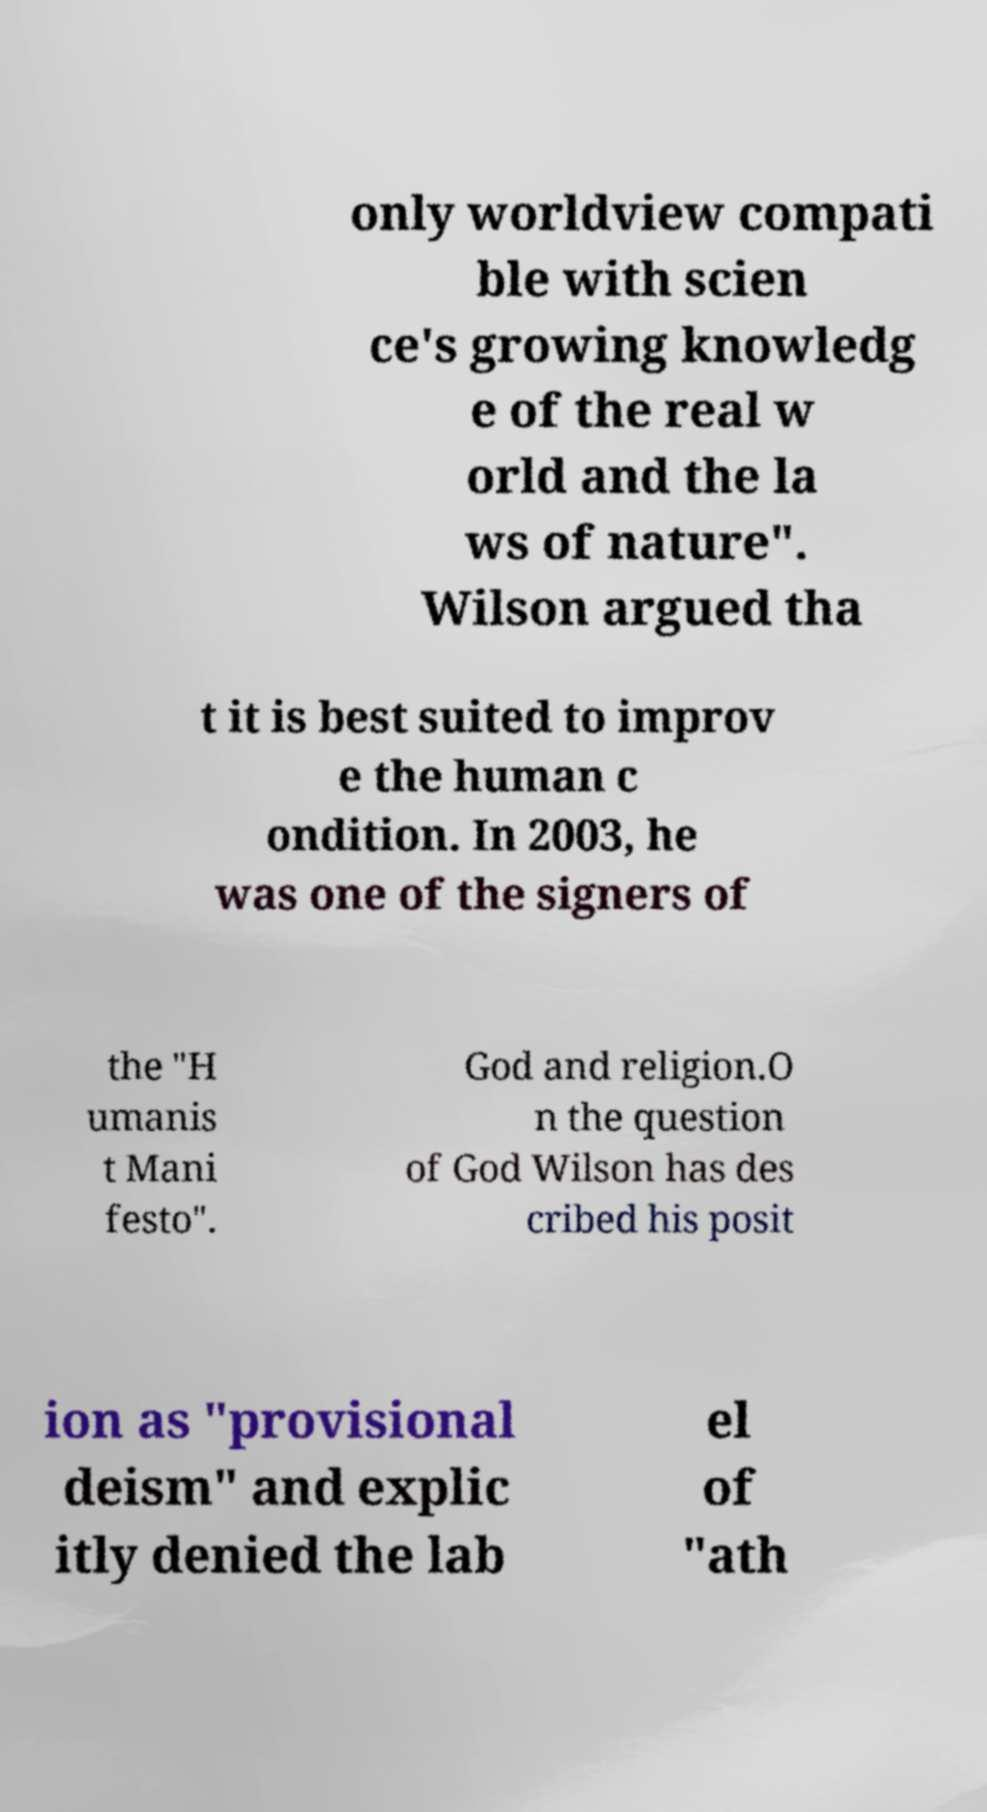Could you extract and type out the text from this image? only worldview compati ble with scien ce's growing knowledg e of the real w orld and the la ws of nature". Wilson argued tha t it is best suited to improv e the human c ondition. In 2003, he was one of the signers of the "H umanis t Mani festo". God and religion.O n the question of God Wilson has des cribed his posit ion as "provisional deism" and explic itly denied the lab el of "ath 